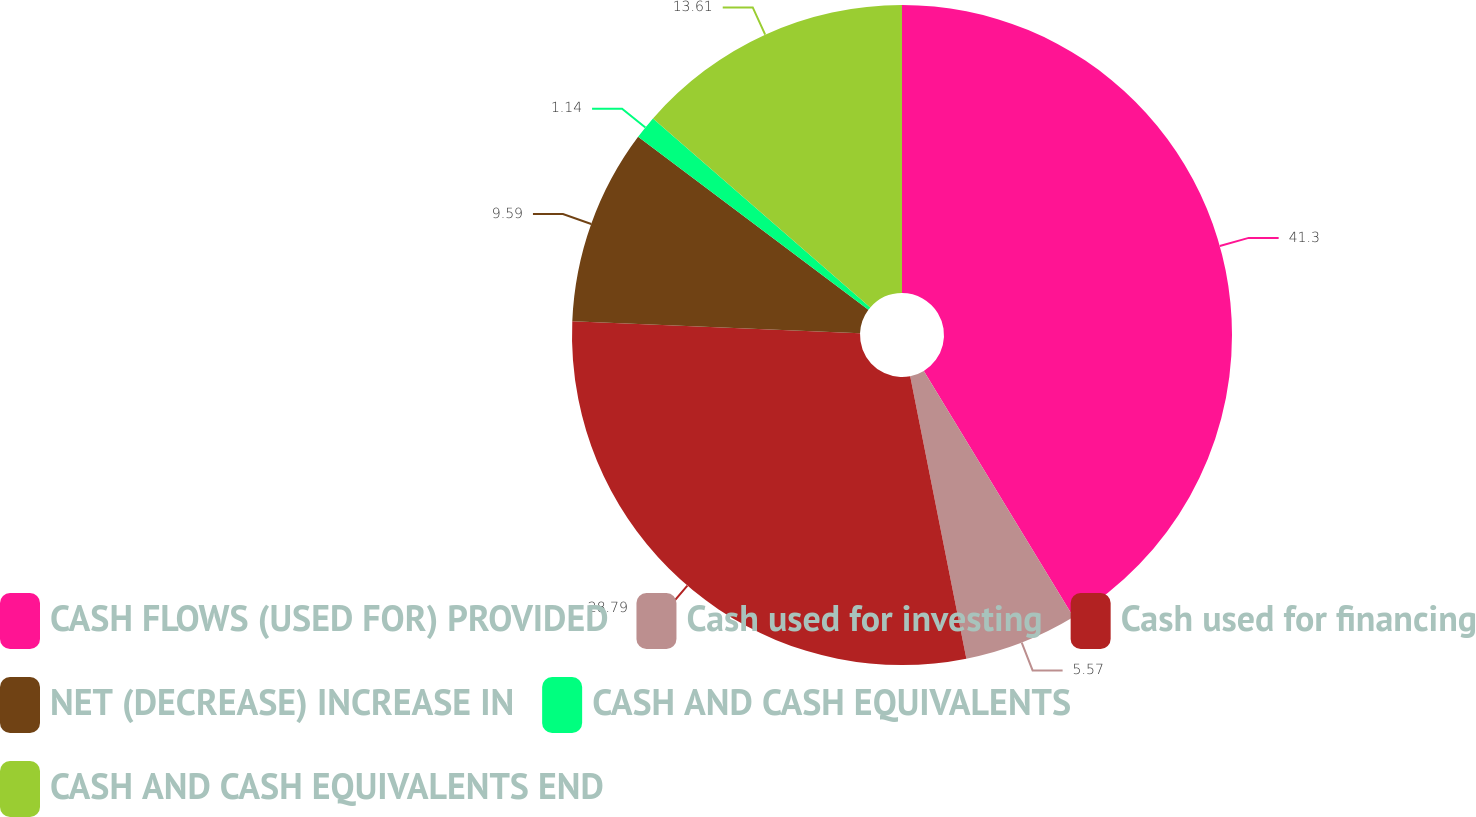Convert chart to OTSL. <chart><loc_0><loc_0><loc_500><loc_500><pie_chart><fcel>CASH FLOWS (USED FOR) PROVIDED<fcel>Cash used for investing<fcel>Cash used for financing<fcel>NET (DECREASE) INCREASE IN<fcel>CASH AND CASH EQUIVALENTS<fcel>CASH AND CASH EQUIVALENTS END<nl><fcel>41.31%<fcel>5.57%<fcel>28.79%<fcel>9.59%<fcel>1.14%<fcel>13.61%<nl></chart> 